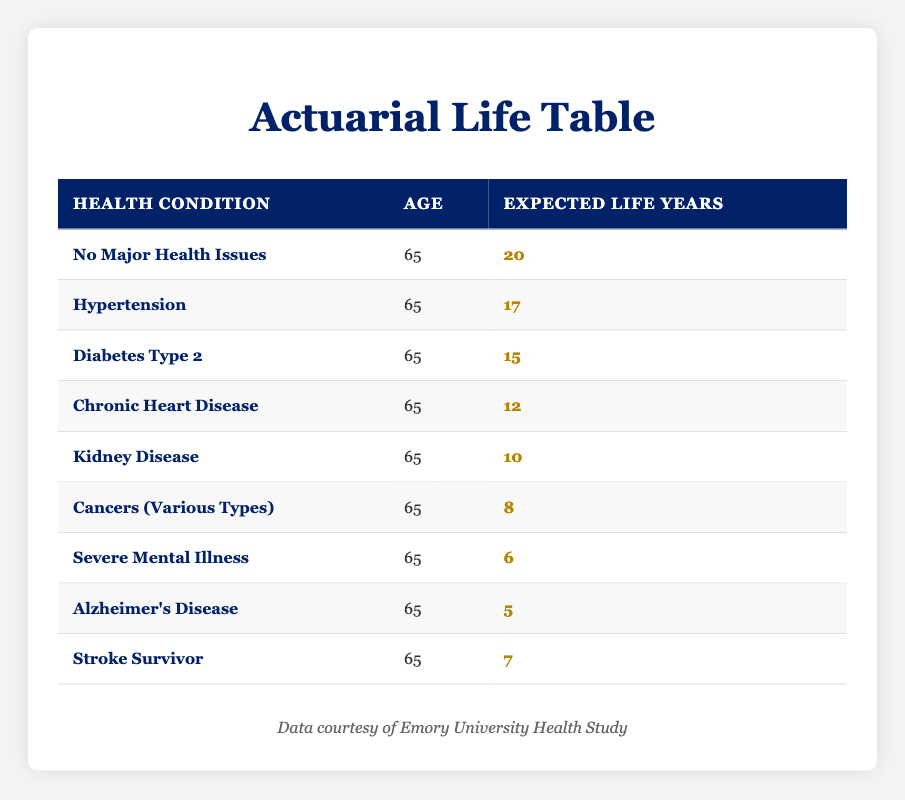What is the expected life years for someone with no major health issues at age 65? According to the table, the entry for "No Major Health Issues" states that the expected life years for individuals at age 65 is 20 years.
Answer: 20 What is the expected life years for someone diagnosed with Diabetes Type 2 at age 65? The table shows that the expected life years for individuals with Diabetes Type 2 at age 65 is 15 years.
Answer: 15 How many more years can a person expect to live at age 65 if they have no major health issues compared to someone with Chronic Heart Disease? The expected life years for someone with no major health issues is 20 years, while for someone with Chronic Heart Disease, it is 12 years. The difference is 20 - 12 = 8 years.
Answer: 8 Are individuals with Alzheimer's Disease expected to live longer than those with Severe Mental Illness at age 65? The table indicates that individuals with Alzheimer's Disease have an expected life of 5 years, while those with Severe Mental Illness have 6 years. Hence, the statement is false.
Answer: No What is the average expected life years for individuals with Kidney Disease, Cancers, and Severe Mental Illness at age 65? The expected life years for these conditions are 10 (Kidney Disease), 8 (Cancers), and 6 (Severe Mental Illness). Summing these gives 10 + 8 + 6 = 24 years. Dividing by 3 (the number of conditions) provides an average of 24 / 3 = 8 years.
Answer: 8 Which health condition results in the least expected life years for someone at age 65? Reviewing the table, "Alzheimer's Disease" has the lowest expected life years at 5 years, making it the health condition with the least life expectancy.
Answer: Alzheimer's Disease What is the total expected life years for individuals at age 65 with Hypertension, Stroke Survivor, and Chronic Heart Disease? The expected life years for Hypertension is 17 years, for Stroke Survivor is 7 years, and for Chronic Heart Disease is 12 years. Adding these values together gives 17 + 7 + 12 = 36 years.
Answer: 36 Is it true that a Stroke Survivor has a higher expected life than a person diagnosed with Kidney Disease? The expected life years for a Stroke Survivor is 7 years, while for someone with Kidney Disease, it is 10 years. Since 7 is less than 10, the statement is false.
Answer: No 